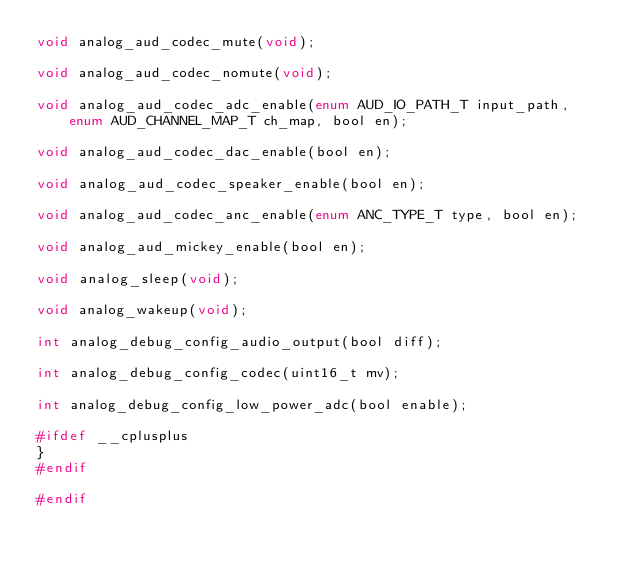<code> <loc_0><loc_0><loc_500><loc_500><_C_>void analog_aud_codec_mute(void);

void analog_aud_codec_nomute(void);

void analog_aud_codec_adc_enable(enum AUD_IO_PATH_T input_path, enum AUD_CHANNEL_MAP_T ch_map, bool en);

void analog_aud_codec_dac_enable(bool en);

void analog_aud_codec_speaker_enable(bool en);

void analog_aud_codec_anc_enable(enum ANC_TYPE_T type, bool en);

void analog_aud_mickey_enable(bool en);

void analog_sleep(void);

void analog_wakeup(void);

int analog_debug_config_audio_output(bool diff);

int analog_debug_config_codec(uint16_t mv);

int analog_debug_config_low_power_adc(bool enable);

#ifdef __cplusplus
}
#endif

#endif

</code> 